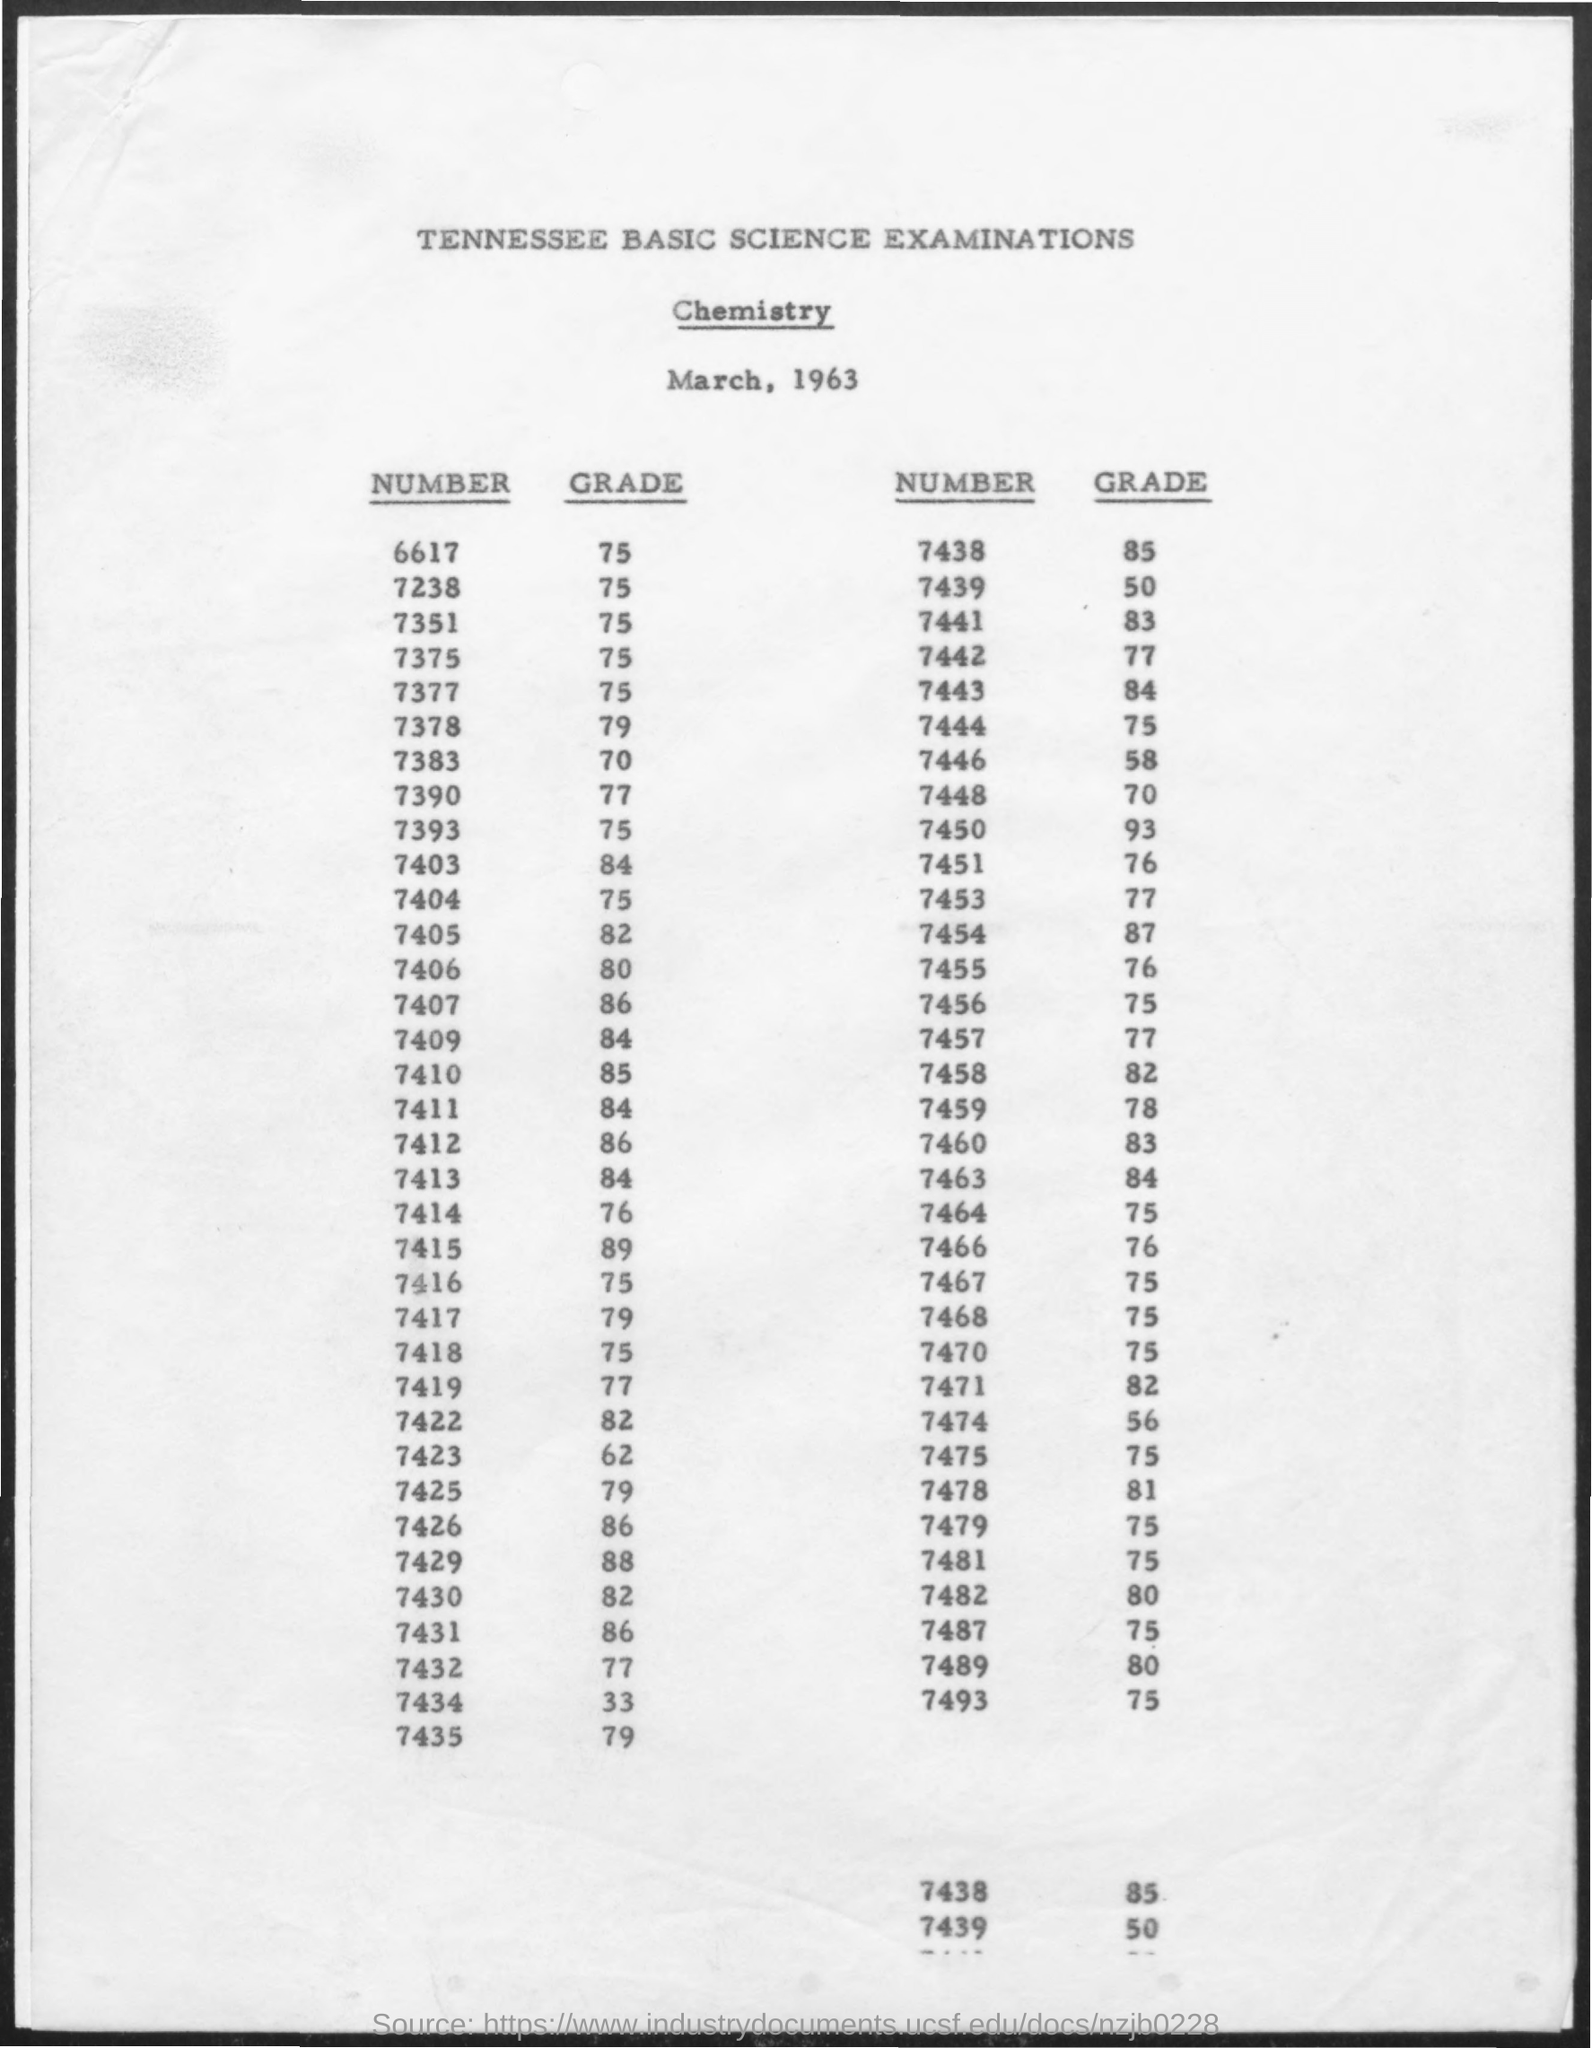What can you tell me about the date and subject of this exam? The document is a score sheet for the Tennessee Basic Science Examinations in Chemistry, dated March, 1963. 